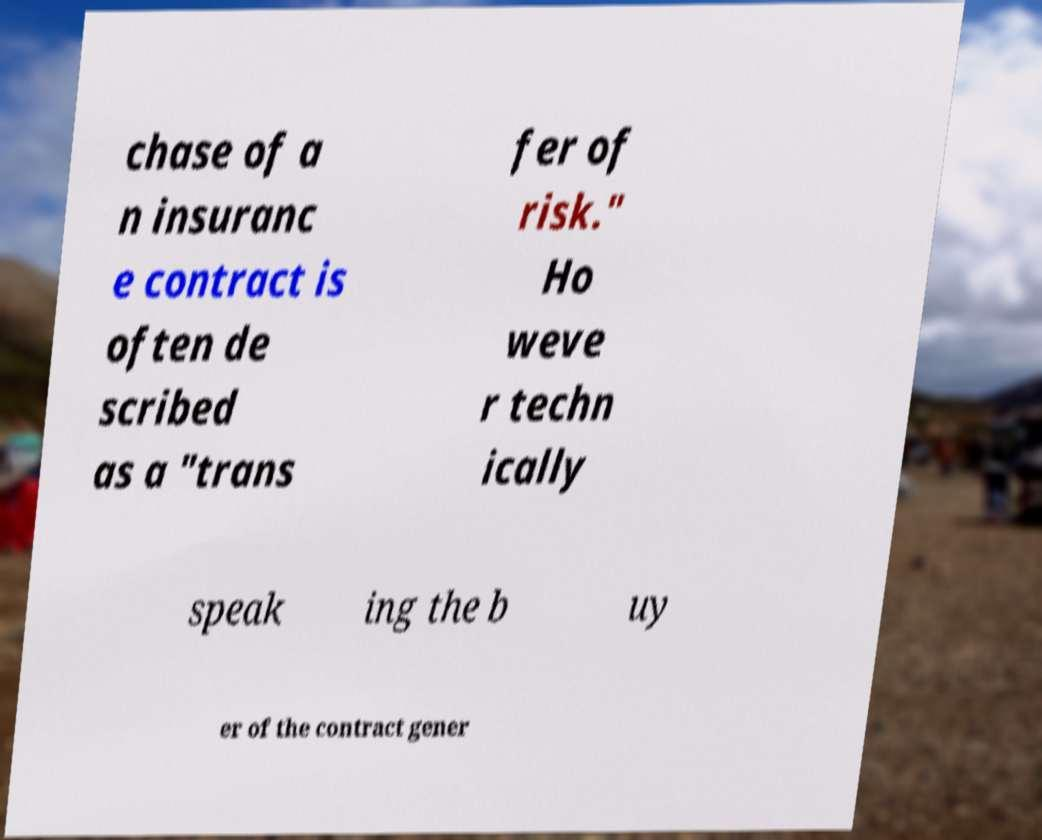There's text embedded in this image that I need extracted. Can you transcribe it verbatim? chase of a n insuranc e contract is often de scribed as a "trans fer of risk." Ho weve r techn ically speak ing the b uy er of the contract gener 